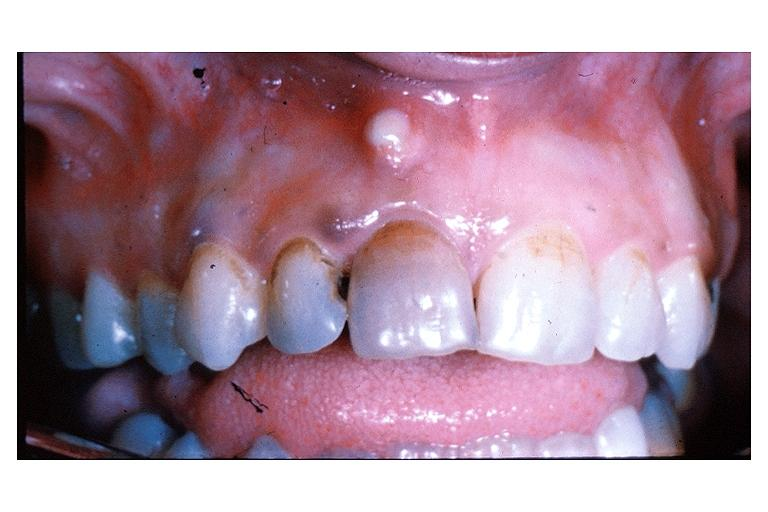where is this?
Answer the question using a single word or phrase. Oral 